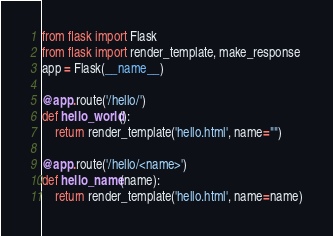<code> <loc_0><loc_0><loc_500><loc_500><_Python_>from flask import Flask
from flask import render_template, make_response
app = Flask(__name__)

@app.route('/hello/')
def hello_world():
	return render_template('hello.html', name="")

@app.route('/hello/<name>')
def hello_name(name):
    return render_template('hello.html', name=name)</code> 